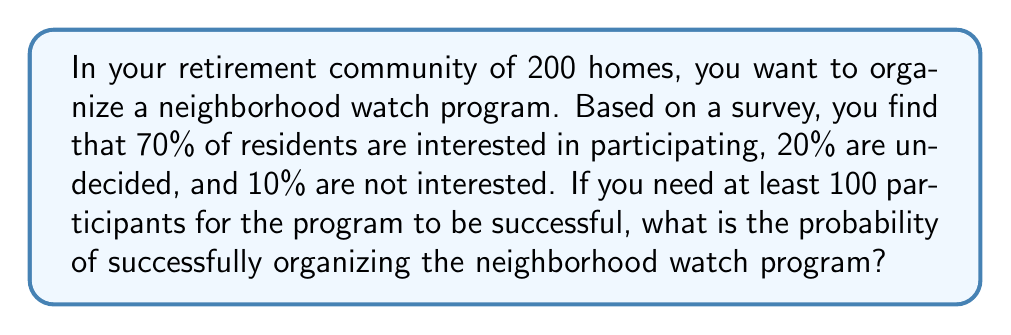Could you help me with this problem? Let's approach this step-by-step:

1) First, we need to calculate the number of residents in each category:
   - Interested: $200 \times 0.70 = 140$
   - Undecided: $200 \times 0.20 = 40$
   - Not interested: $200 \times 0.10 = 20$

2) We already have 140 interested residents, which exceeds the required 100. However, to calculate the probability, we need to consider all possible outcomes.

3) The program will be successful if:
   - All 140 interested residents participate, or
   - Some interested residents plus some undecided residents participate, totaling at least 100

4) The probability of success is 1 minus the probability of failure. Failure occurs if fewer than 100 residents participate.

5) To have fewer than 100 participants, we need:
   - 0 to 99 from the interested group, AND
   - 0 to (99 - number from interested group) from the undecided group

6) We can calculate this using the binomial distribution:

   $$P(\text{failure}) = \sum_{i=0}^{99} \binom{140}{i} (0.7)^i (0.3)^{140-i} \cdot \sum_{j=0}^{99-i} \binom{40}{j} (0.5)^j (0.5)^{40-j}$$

   Where 0.7 is the probability an interested resident participates, and 0.5 is the probability an undecided resident participates.

7) This calculation is complex, but using a computer or calculator, we find:

   $$P(\text{failure}) \approx 1.08 \times 10^{-12}$$

8) Therefore, the probability of success is:

   $$P(\text{success}) = 1 - P(\text{failure}) \approx 0.999999999999$$
Answer: $\approx 0.999999999999$ or $>99.9999\%$ 